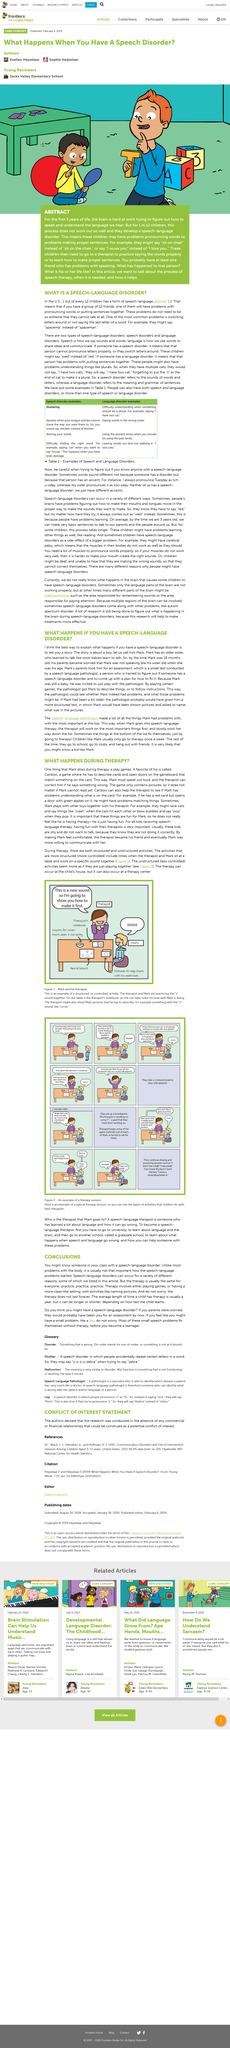Outline some significant characteristics in this image. The name of the boy mentioned in this article is Mark. This article is discussing a speech-language disorder. A speech-language disorder is characterized by difficulties in pronunciation and the inability to form proper sentences. Yes, people with speech-language disorders are still able to communicate effectively through speech. The extent of the disorder may not be significant in all cases. According to recent studies, approximately 1 in 12 children develop a speech-language disorder. 